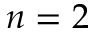<formula> <loc_0><loc_0><loc_500><loc_500>n = 2</formula> 